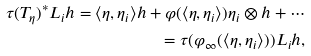<formula> <loc_0><loc_0><loc_500><loc_500>\tau ( T _ { \eta } ) ^ { \ast } L _ { i } h = \langle \eta , \eta _ { i } \rangle h + \varphi ( \langle \eta , \eta _ { i } \rangle ) \eta _ { i } \otimes h + \cdots \\ = \tau ( \varphi _ { \infty } ( \langle \eta , \eta _ { i } \rangle ) ) L _ { i } h \text {,}</formula> 